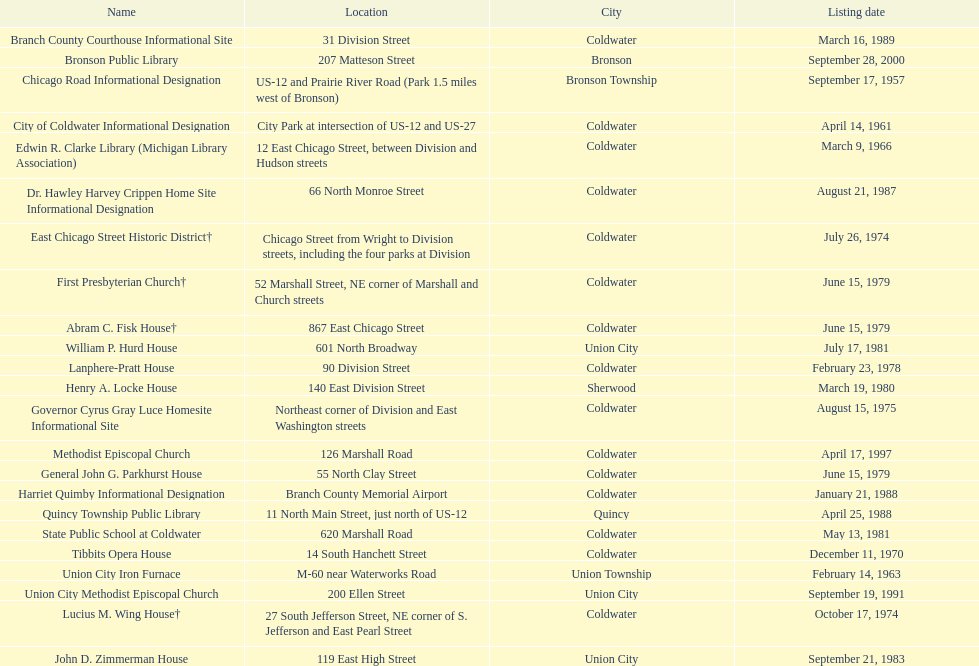Could you help me parse every detail presented in this table? {'header': ['Name', 'Location', 'City', 'Listing date'], 'rows': [['Branch County Courthouse Informational Site', '31 Division Street', 'Coldwater', 'March 16, 1989'], ['Bronson Public Library', '207 Matteson Street', 'Bronson', 'September 28, 2000'], ['Chicago Road Informational Designation', 'US-12 and Prairie River Road (Park 1.5 miles west of Bronson)', 'Bronson Township', 'September 17, 1957'], ['City of Coldwater Informational Designation', 'City Park at intersection of US-12 and US-27', 'Coldwater', 'April 14, 1961'], ['Edwin R. Clarke Library (Michigan Library Association)', '12 East Chicago Street, between Division and Hudson streets', 'Coldwater', 'March 9, 1966'], ['Dr. Hawley Harvey Crippen Home Site Informational Designation', '66 North Monroe Street', 'Coldwater', 'August 21, 1987'], ['East Chicago Street Historic District†', 'Chicago Street from Wright to Division streets, including the four parks at Division', 'Coldwater', 'July 26, 1974'], ['First Presbyterian Church†', '52 Marshall Street, NE corner of Marshall and Church streets', 'Coldwater', 'June 15, 1979'], ['Abram C. Fisk House†', '867 East Chicago Street', 'Coldwater', 'June 15, 1979'], ['William P. Hurd House', '601 North Broadway', 'Union City', 'July 17, 1981'], ['Lanphere-Pratt House', '90 Division Street', 'Coldwater', 'February 23, 1978'], ['Henry A. Locke House', '140 East Division Street', 'Sherwood', 'March 19, 1980'], ['Governor Cyrus Gray Luce Homesite Informational Site', 'Northeast corner of Division and East Washington streets', 'Coldwater', 'August 15, 1975'], ['Methodist Episcopal Church', '126 Marshall Road', 'Coldwater', 'April 17, 1997'], ['General John G. Parkhurst House', '55 North Clay Street', 'Coldwater', 'June 15, 1979'], ['Harriet Quimby Informational Designation', 'Branch County Memorial Airport', 'Coldwater', 'January 21, 1988'], ['Quincy Township Public Library', '11 North Main Street, just north of US-12', 'Quincy', 'April 25, 1988'], ['State Public School at Coldwater', '620 Marshall Road', 'Coldwater', 'May 13, 1981'], ['Tibbits Opera House', '14 South Hanchett Street', 'Coldwater', 'December 11, 1970'], ['Union City Iron Furnace', 'M-60 near Waterworks Road', 'Union Township', 'February 14, 1963'], ['Union City Methodist Episcopal Church', '200 Ellen Street', 'Union City', 'September 19, 1991'], ['Lucius M. Wing House†', '27 South Jefferson Street, NE corner of S. Jefferson and East Pearl Street', 'Coldwater', 'October 17, 1974'], ['John D. Zimmerman House', '119 East High Street', 'Union City', 'September 21, 1983']]} Which site was listed earlier, the state public school or the edwin r. clarke library? Edwin R. Clarke Library. 